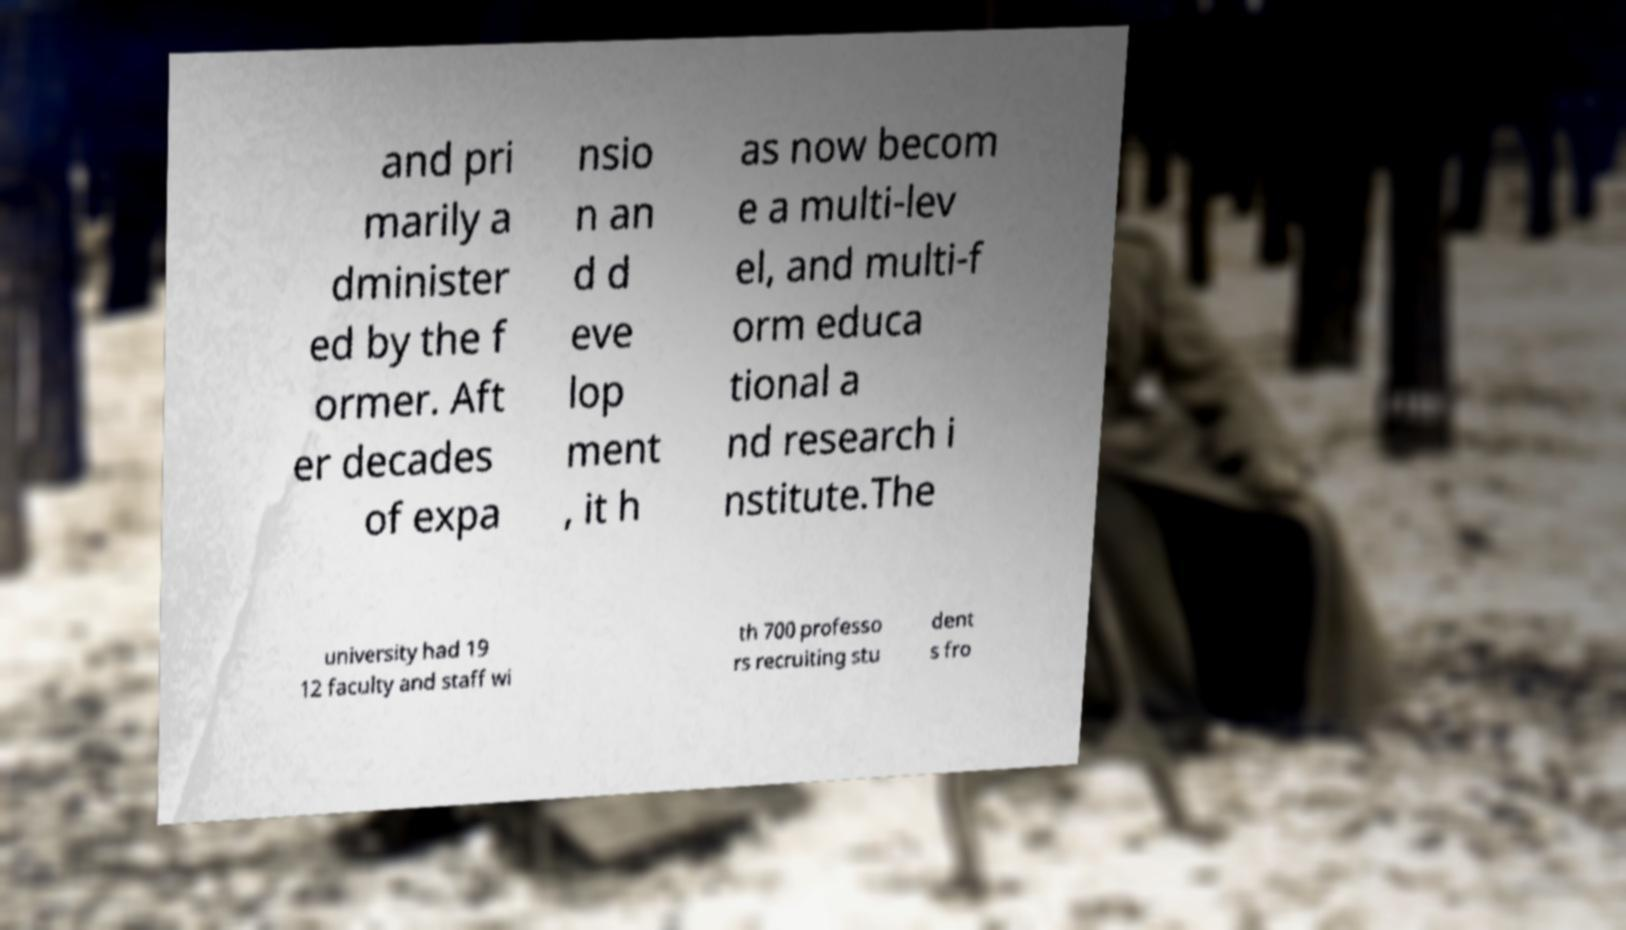Could you assist in decoding the text presented in this image and type it out clearly? and pri marily a dminister ed by the f ormer. Aft er decades of expa nsio n an d d eve lop ment , it h as now becom e a multi-lev el, and multi-f orm educa tional a nd research i nstitute.The university had 19 12 faculty and staff wi th 700 professo rs recruiting stu dent s fro 